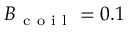Convert formula to latex. <formula><loc_0><loc_0><loc_500><loc_500>B _ { c o i l } = 0 . 1</formula> 